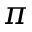Convert formula to latex. <formula><loc_0><loc_0><loc_500><loc_500>\pi</formula> 